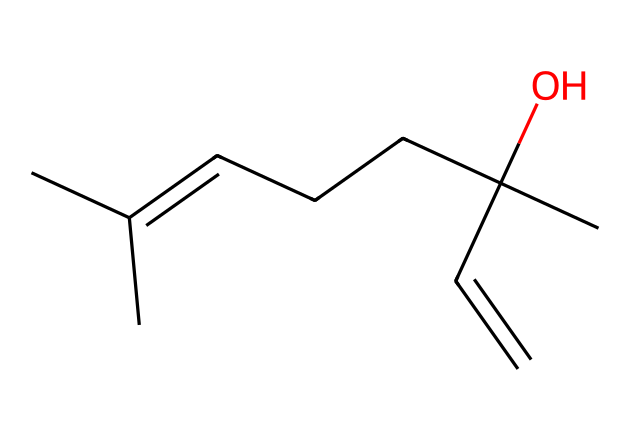What is the molecular formula of linalool? To determine the molecular formula from the SMILES representation CC(C)=CCCC(C)(O)C=C, we count the number of carbon (C), hydrogen (H), and oxygen (O) atoms. There are 10 carbon atoms, 18 hydrogen atoms, and 1 oxygen atom. Therefore, the molecular formula is C10H18O.
Answer: C10H18O How many chiral centers are present in linalool? By analyzing the structure represented in the SMILES, we identify the carbon atoms that are bonded to four different substituents. In this case, there is one chiral center at the C with the hydroxyl (O) group and two other alkyl groups. Thus, there is 1 chiral center.
Answer: 1 What type of compound is linalool classified as? Linalool contains both hydroxyl (-OH) and alkene (C=C) functional groups, which qualifies it as an alcohol and a terpenoid, specifically a monoterpene alcohol. Therefore, linalool is categorized primarily as a terpenoid.
Answer: terpenoid What is the significance of linalool's chirality in perfumes? The chirality of linalool means that it can exist in two mirror-image forms (enantiomers), which can have different scents and olfactory properties, affecting the fragrance profile in perfumes and aromatherapy. Thus, its chirality significantly influences its scent.
Answer: scent difference Are there any known biological activities associated with linalool? Research indicates that linalool possesses various biological activities, including anti-inflammatory, analgesic, and antioxidant properties, making it useful in both aromatherapy and potential therapeutic applications.
Answer: yes 